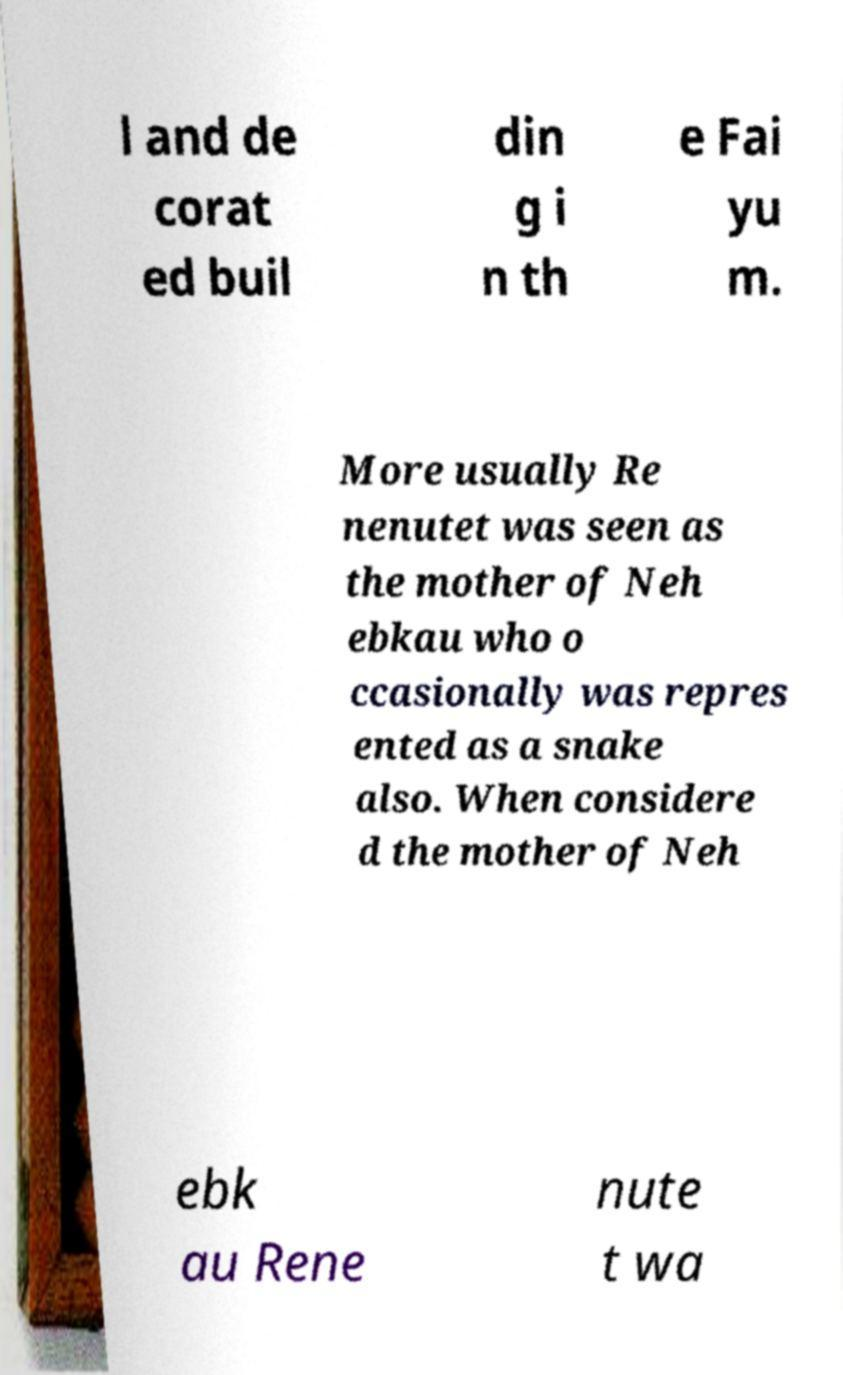Please identify and transcribe the text found in this image. l and de corat ed buil din g i n th e Fai yu m. More usually Re nenutet was seen as the mother of Neh ebkau who o ccasionally was repres ented as a snake also. When considere d the mother of Neh ebk au Rene nute t wa 